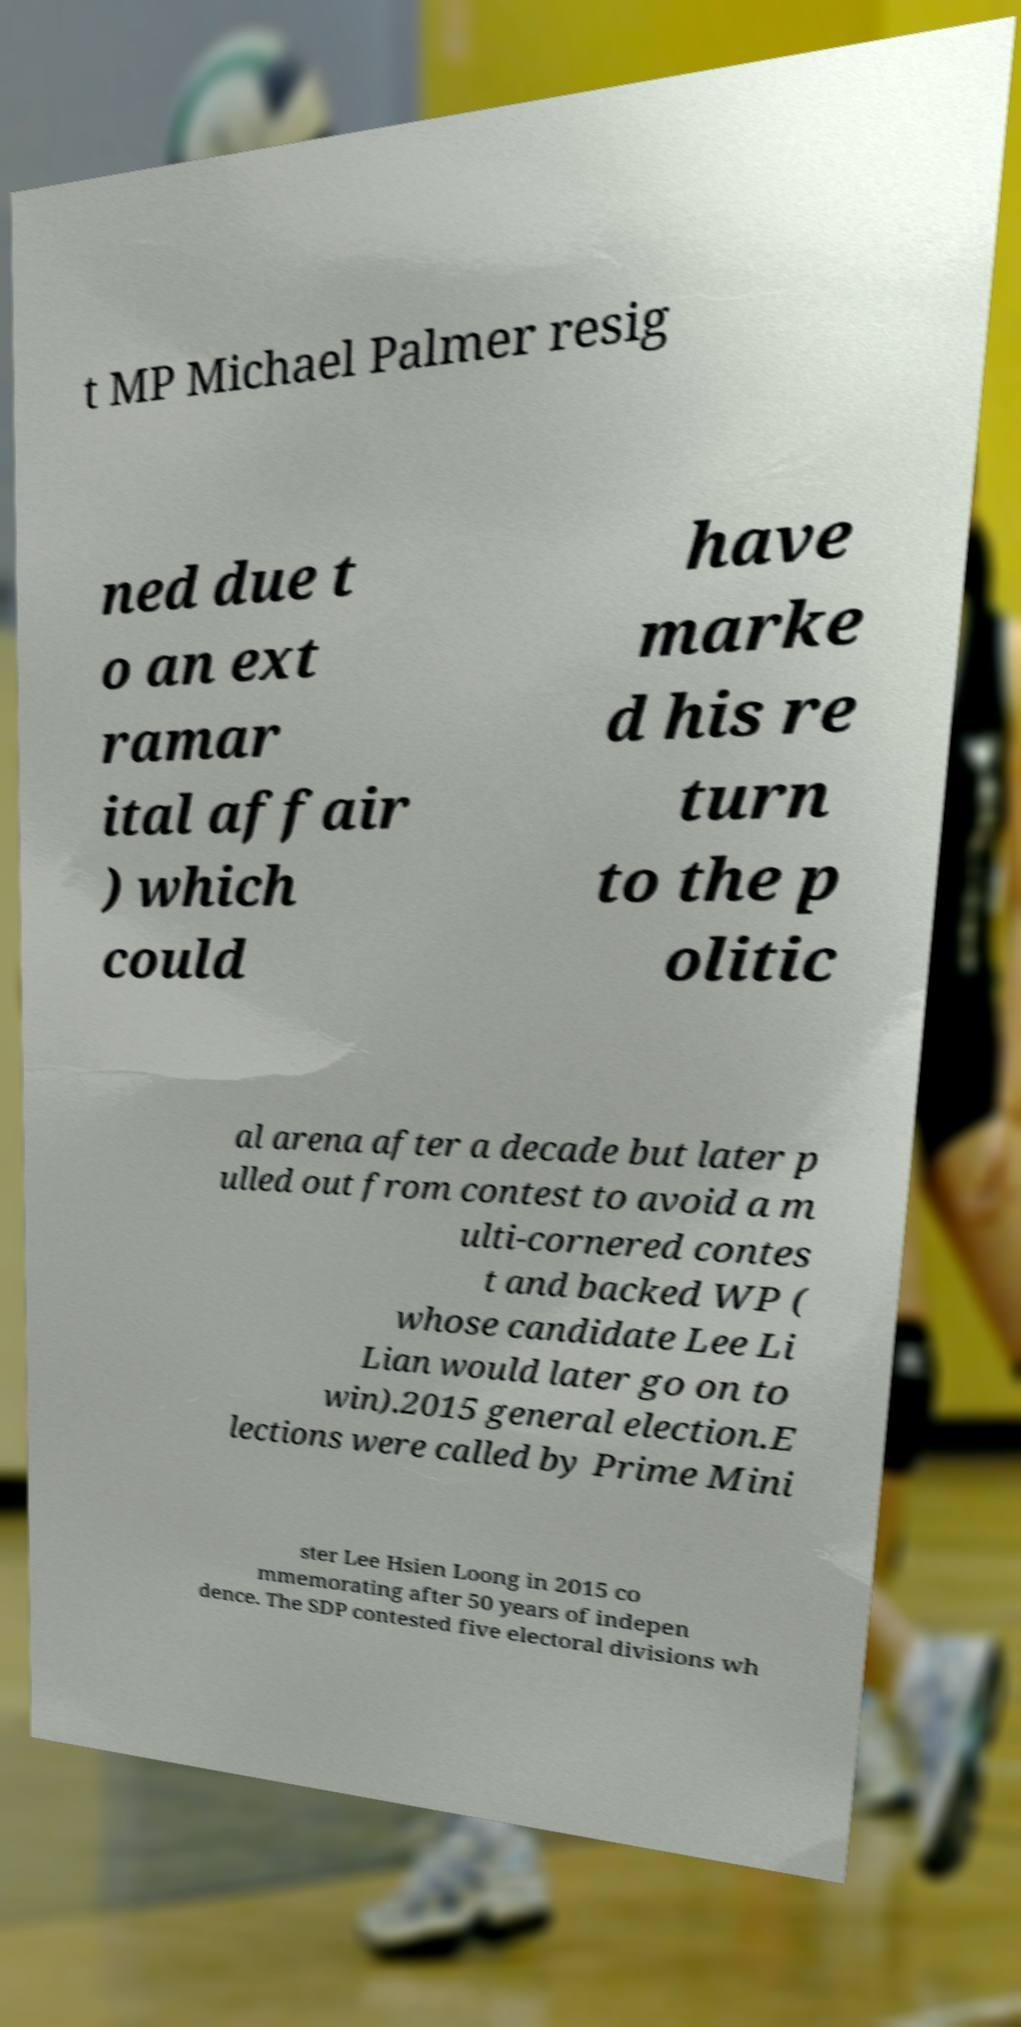Please identify and transcribe the text found in this image. t MP Michael Palmer resig ned due t o an ext ramar ital affair ) which could have marke d his re turn to the p olitic al arena after a decade but later p ulled out from contest to avoid a m ulti-cornered contes t and backed WP ( whose candidate Lee Li Lian would later go on to win).2015 general election.E lections were called by Prime Mini ster Lee Hsien Loong in 2015 co mmemorating after 50 years of indepen dence. The SDP contested five electoral divisions wh 